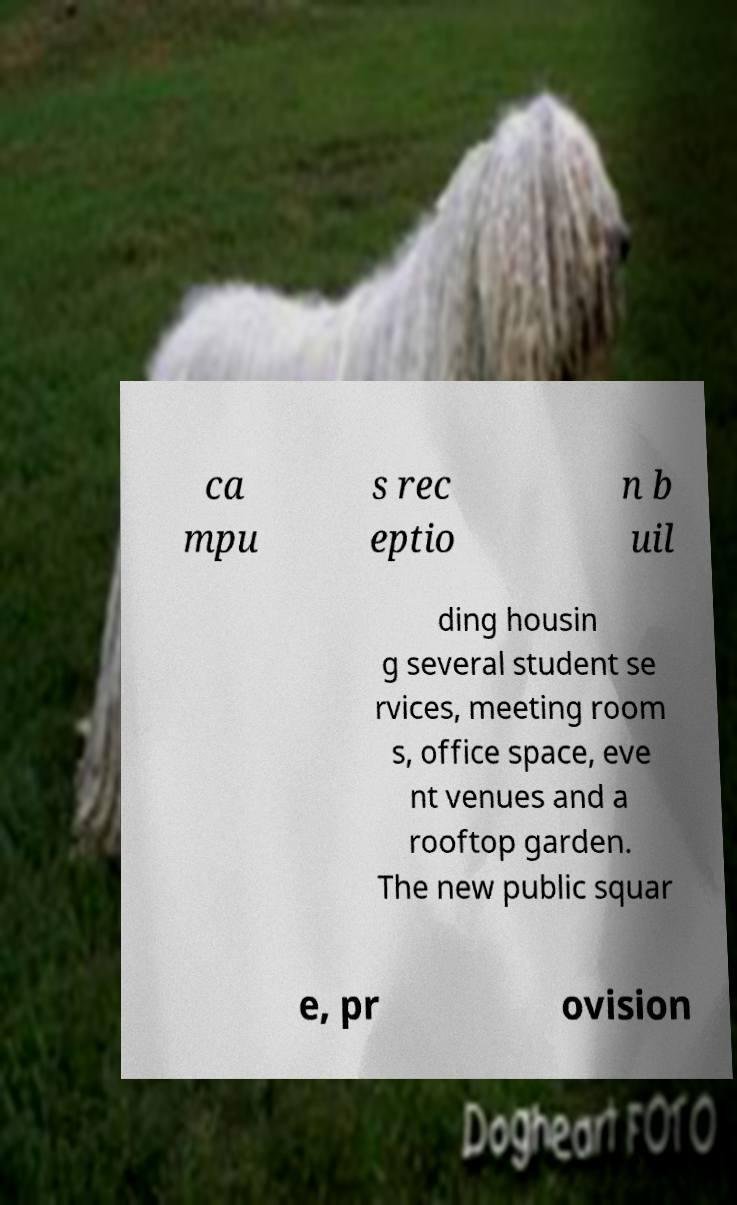Please read and relay the text visible in this image. What does it say? ca mpu s rec eptio n b uil ding housin g several student se rvices, meeting room s, office space, eve nt venues and a rooftop garden. The new public squar e, pr ovision 